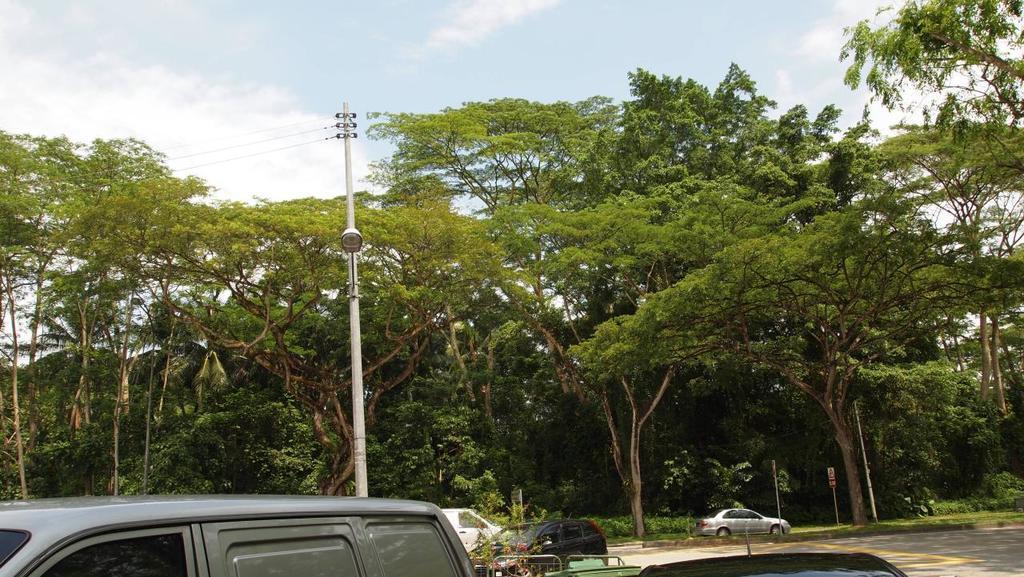Please provide a concise description of this image. This image is taken on the road. In this image there are vehicles on the road. In the middle there is an electric pole to which there is a light. In the background there are trees. At the top there is the sky. 